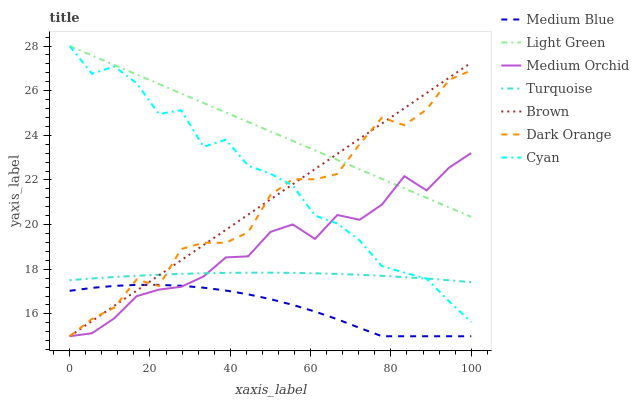Does Medium Blue have the minimum area under the curve?
Answer yes or no. Yes. Does Light Green have the maximum area under the curve?
Answer yes or no. Yes. Does Turquoise have the minimum area under the curve?
Answer yes or no. No. Does Turquoise have the maximum area under the curve?
Answer yes or no. No. Is Brown the smoothest?
Answer yes or no. Yes. Is Cyan the roughest?
Answer yes or no. Yes. Is Turquoise the smoothest?
Answer yes or no. No. Is Turquoise the roughest?
Answer yes or no. No. Does Brown have the lowest value?
Answer yes or no. Yes. Does Turquoise have the lowest value?
Answer yes or no. No. Does Cyan have the highest value?
Answer yes or no. Yes. Does Turquoise have the highest value?
Answer yes or no. No. Is Medium Blue less than Turquoise?
Answer yes or no. Yes. Is Light Green greater than Medium Blue?
Answer yes or no. Yes. Does Cyan intersect Dark Orange?
Answer yes or no. Yes. Is Cyan less than Dark Orange?
Answer yes or no. No. Is Cyan greater than Dark Orange?
Answer yes or no. No. Does Medium Blue intersect Turquoise?
Answer yes or no. No. 